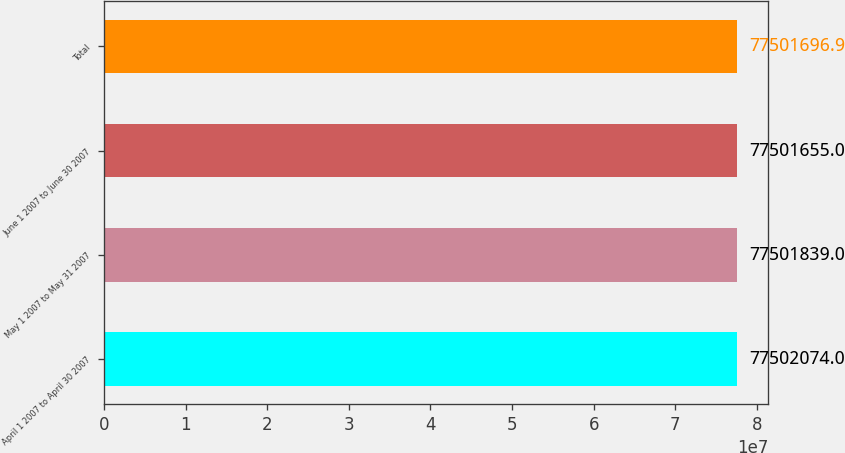Convert chart to OTSL. <chart><loc_0><loc_0><loc_500><loc_500><bar_chart><fcel>April 1 2007 to April 30 2007<fcel>May 1 2007 to May 31 2007<fcel>June 1 2007 to June 30 2007<fcel>Total<nl><fcel>7.75021e+07<fcel>7.75018e+07<fcel>7.75017e+07<fcel>7.75017e+07<nl></chart> 